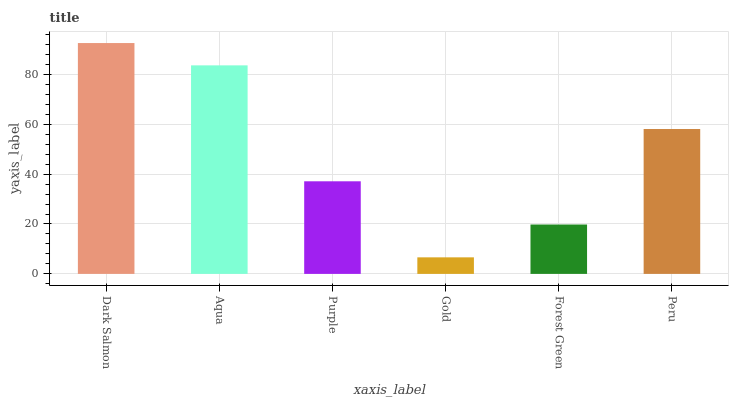Is Gold the minimum?
Answer yes or no. Yes. Is Dark Salmon the maximum?
Answer yes or no. Yes. Is Aqua the minimum?
Answer yes or no. No. Is Aqua the maximum?
Answer yes or no. No. Is Dark Salmon greater than Aqua?
Answer yes or no. Yes. Is Aqua less than Dark Salmon?
Answer yes or no. Yes. Is Aqua greater than Dark Salmon?
Answer yes or no. No. Is Dark Salmon less than Aqua?
Answer yes or no. No. Is Peru the high median?
Answer yes or no. Yes. Is Purple the low median?
Answer yes or no. Yes. Is Gold the high median?
Answer yes or no. No. Is Dark Salmon the low median?
Answer yes or no. No. 